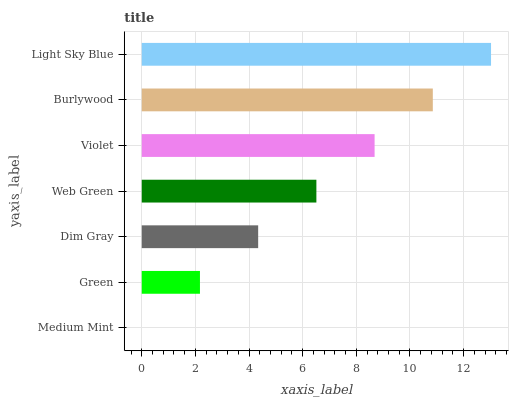Is Medium Mint the minimum?
Answer yes or no. Yes. Is Light Sky Blue the maximum?
Answer yes or no. Yes. Is Green the minimum?
Answer yes or no. No. Is Green the maximum?
Answer yes or no. No. Is Green greater than Medium Mint?
Answer yes or no. Yes. Is Medium Mint less than Green?
Answer yes or no. Yes. Is Medium Mint greater than Green?
Answer yes or no. No. Is Green less than Medium Mint?
Answer yes or no. No. Is Web Green the high median?
Answer yes or no. Yes. Is Web Green the low median?
Answer yes or no. Yes. Is Light Sky Blue the high median?
Answer yes or no. No. Is Green the low median?
Answer yes or no. No. 